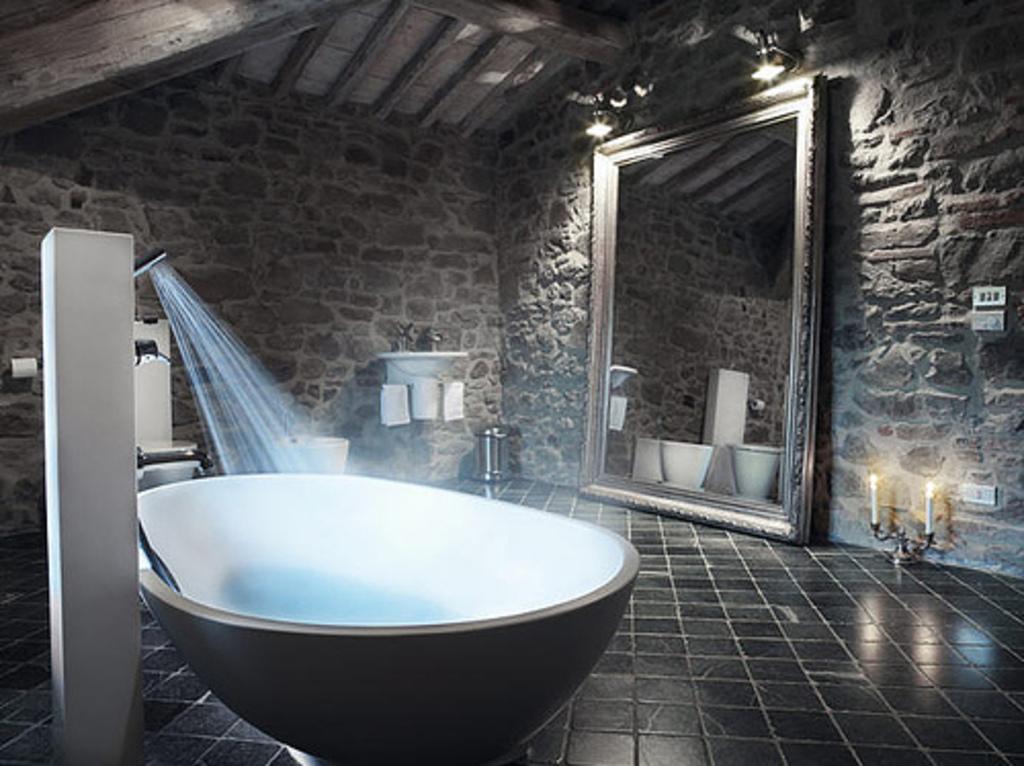Could you give a brief overview of what you see in this image? In this image, I can see a bathtub. This looks like a hand shower with the water. I can see a toilet seat. This is a wash basin, which is attached to the wall. These are the napkins. I can see a dustbin. This is a mirror. I can see the reflection of a toilet seat and few other objects in the mirror. These are the candles on a candle stand. I think these are the switchboards. I can see the lamps attached to the wall. 